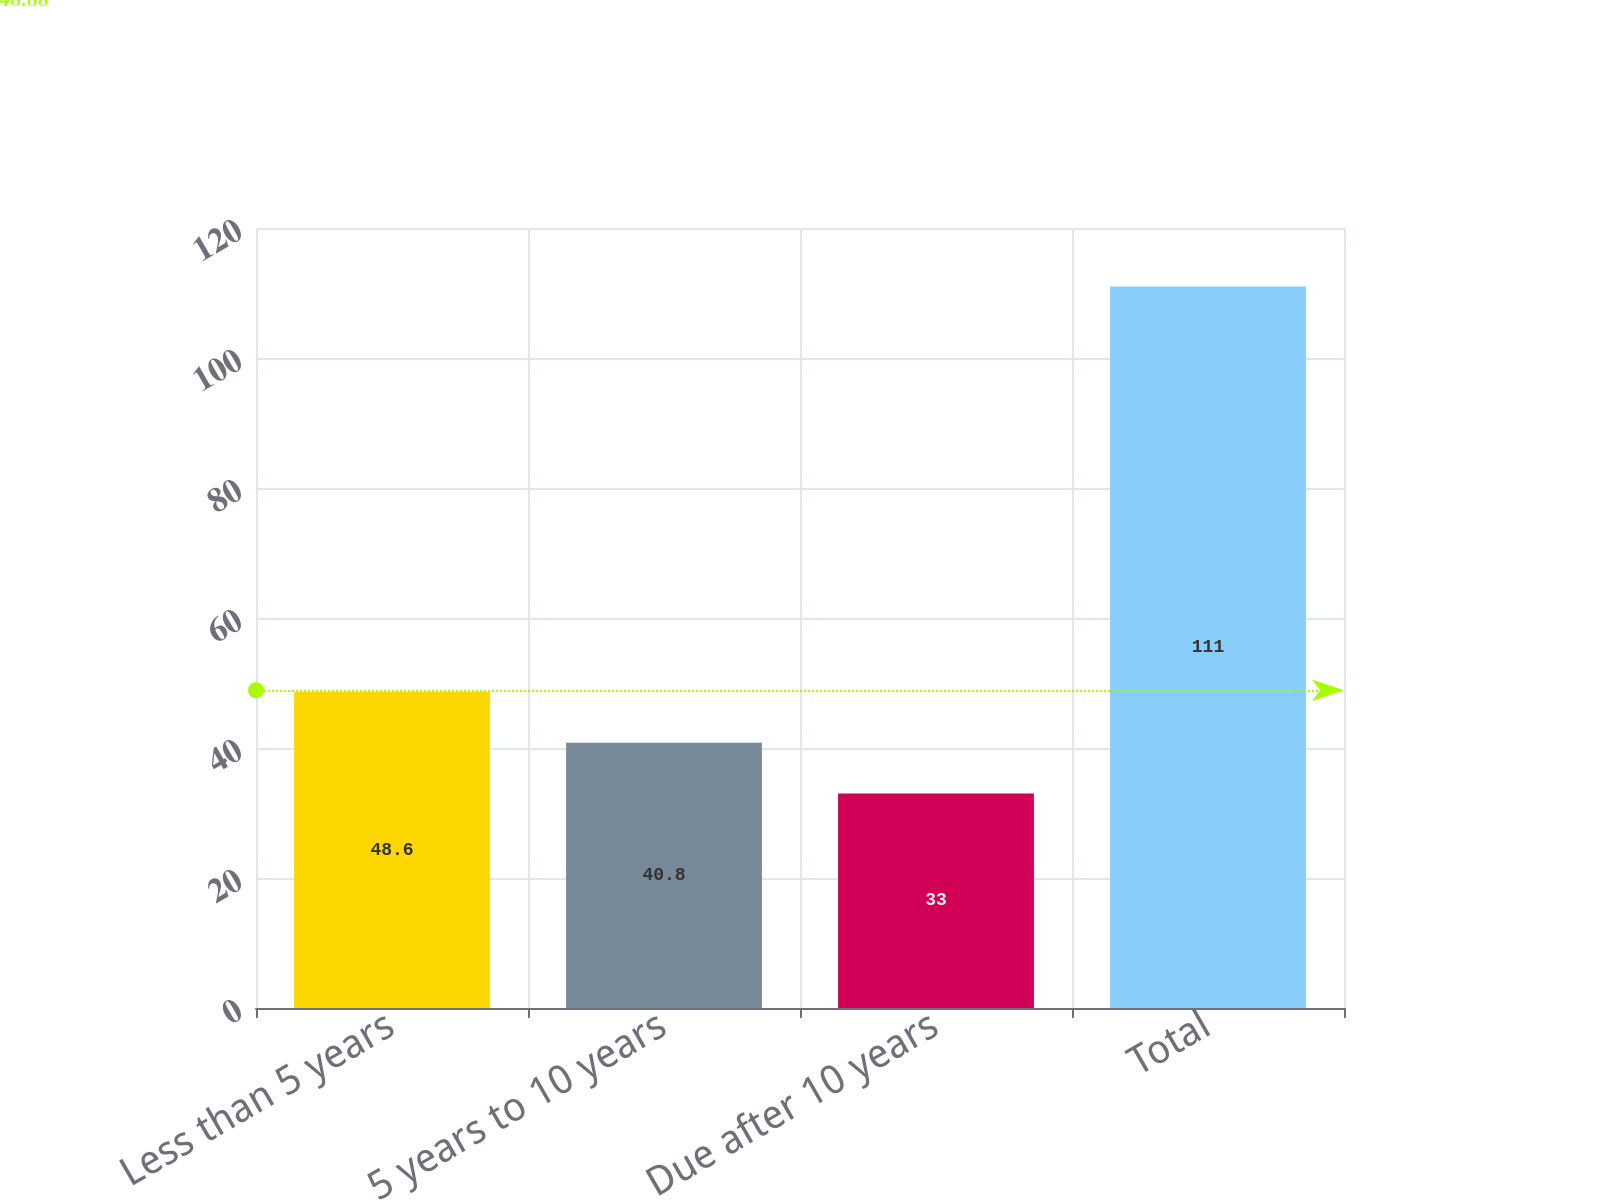Convert chart to OTSL. <chart><loc_0><loc_0><loc_500><loc_500><bar_chart><fcel>Less than 5 years<fcel>5 years to 10 years<fcel>Due after 10 years<fcel>Total<nl><fcel>48.6<fcel>40.8<fcel>33<fcel>111<nl></chart> 